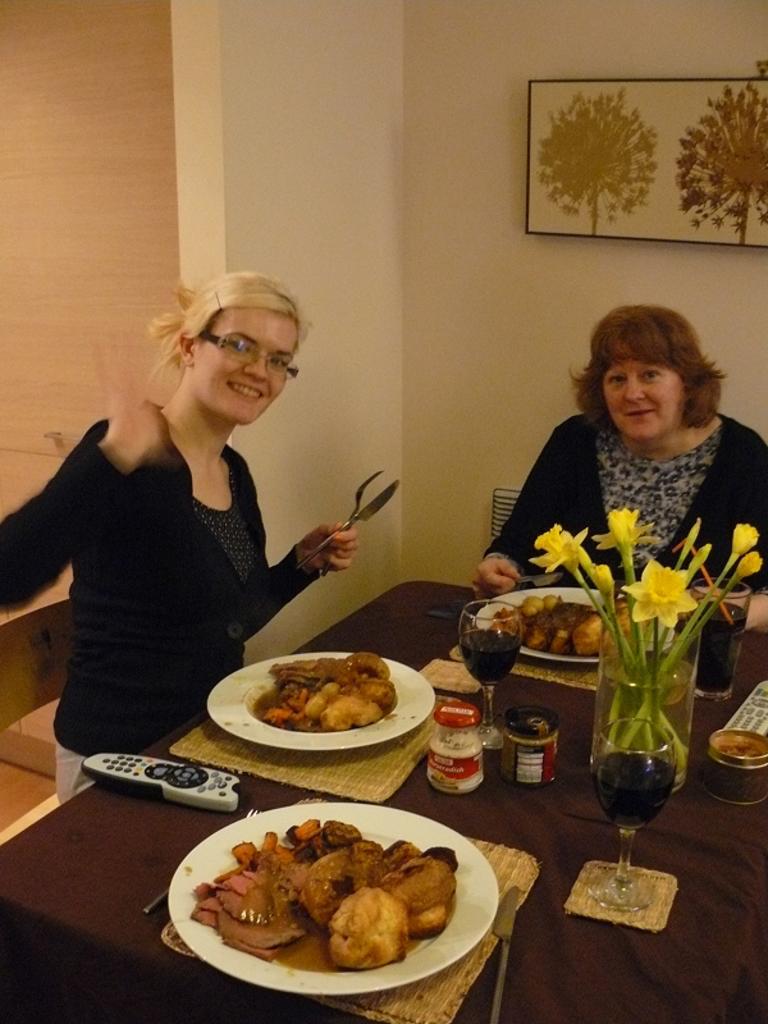How would you summarize this image in a sentence or two? In this image I see 2 women who are sitting on the chairs and I also see that both of them are smiling. I see that there is a table in front in which there are 3 plates and there are food in it and I see 2 glasses, a flower vase and few things on it. In the background I see the wall and a photo frame. 